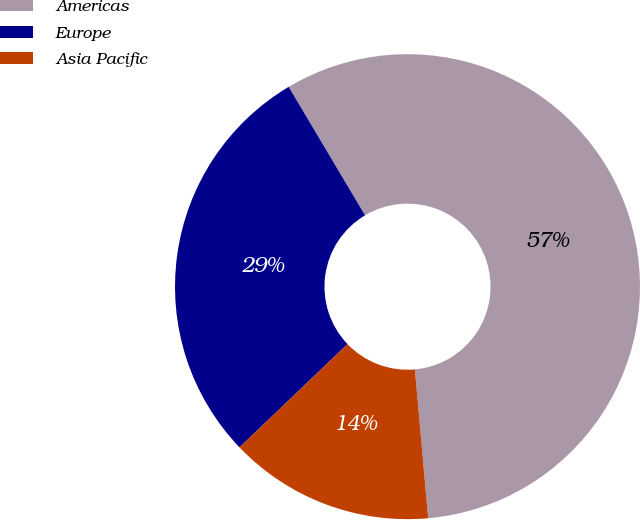Convert chart to OTSL. <chart><loc_0><loc_0><loc_500><loc_500><pie_chart><fcel>Americas<fcel>Europe<fcel>Asia Pacific<nl><fcel>57.12%<fcel>28.61%<fcel>14.27%<nl></chart> 